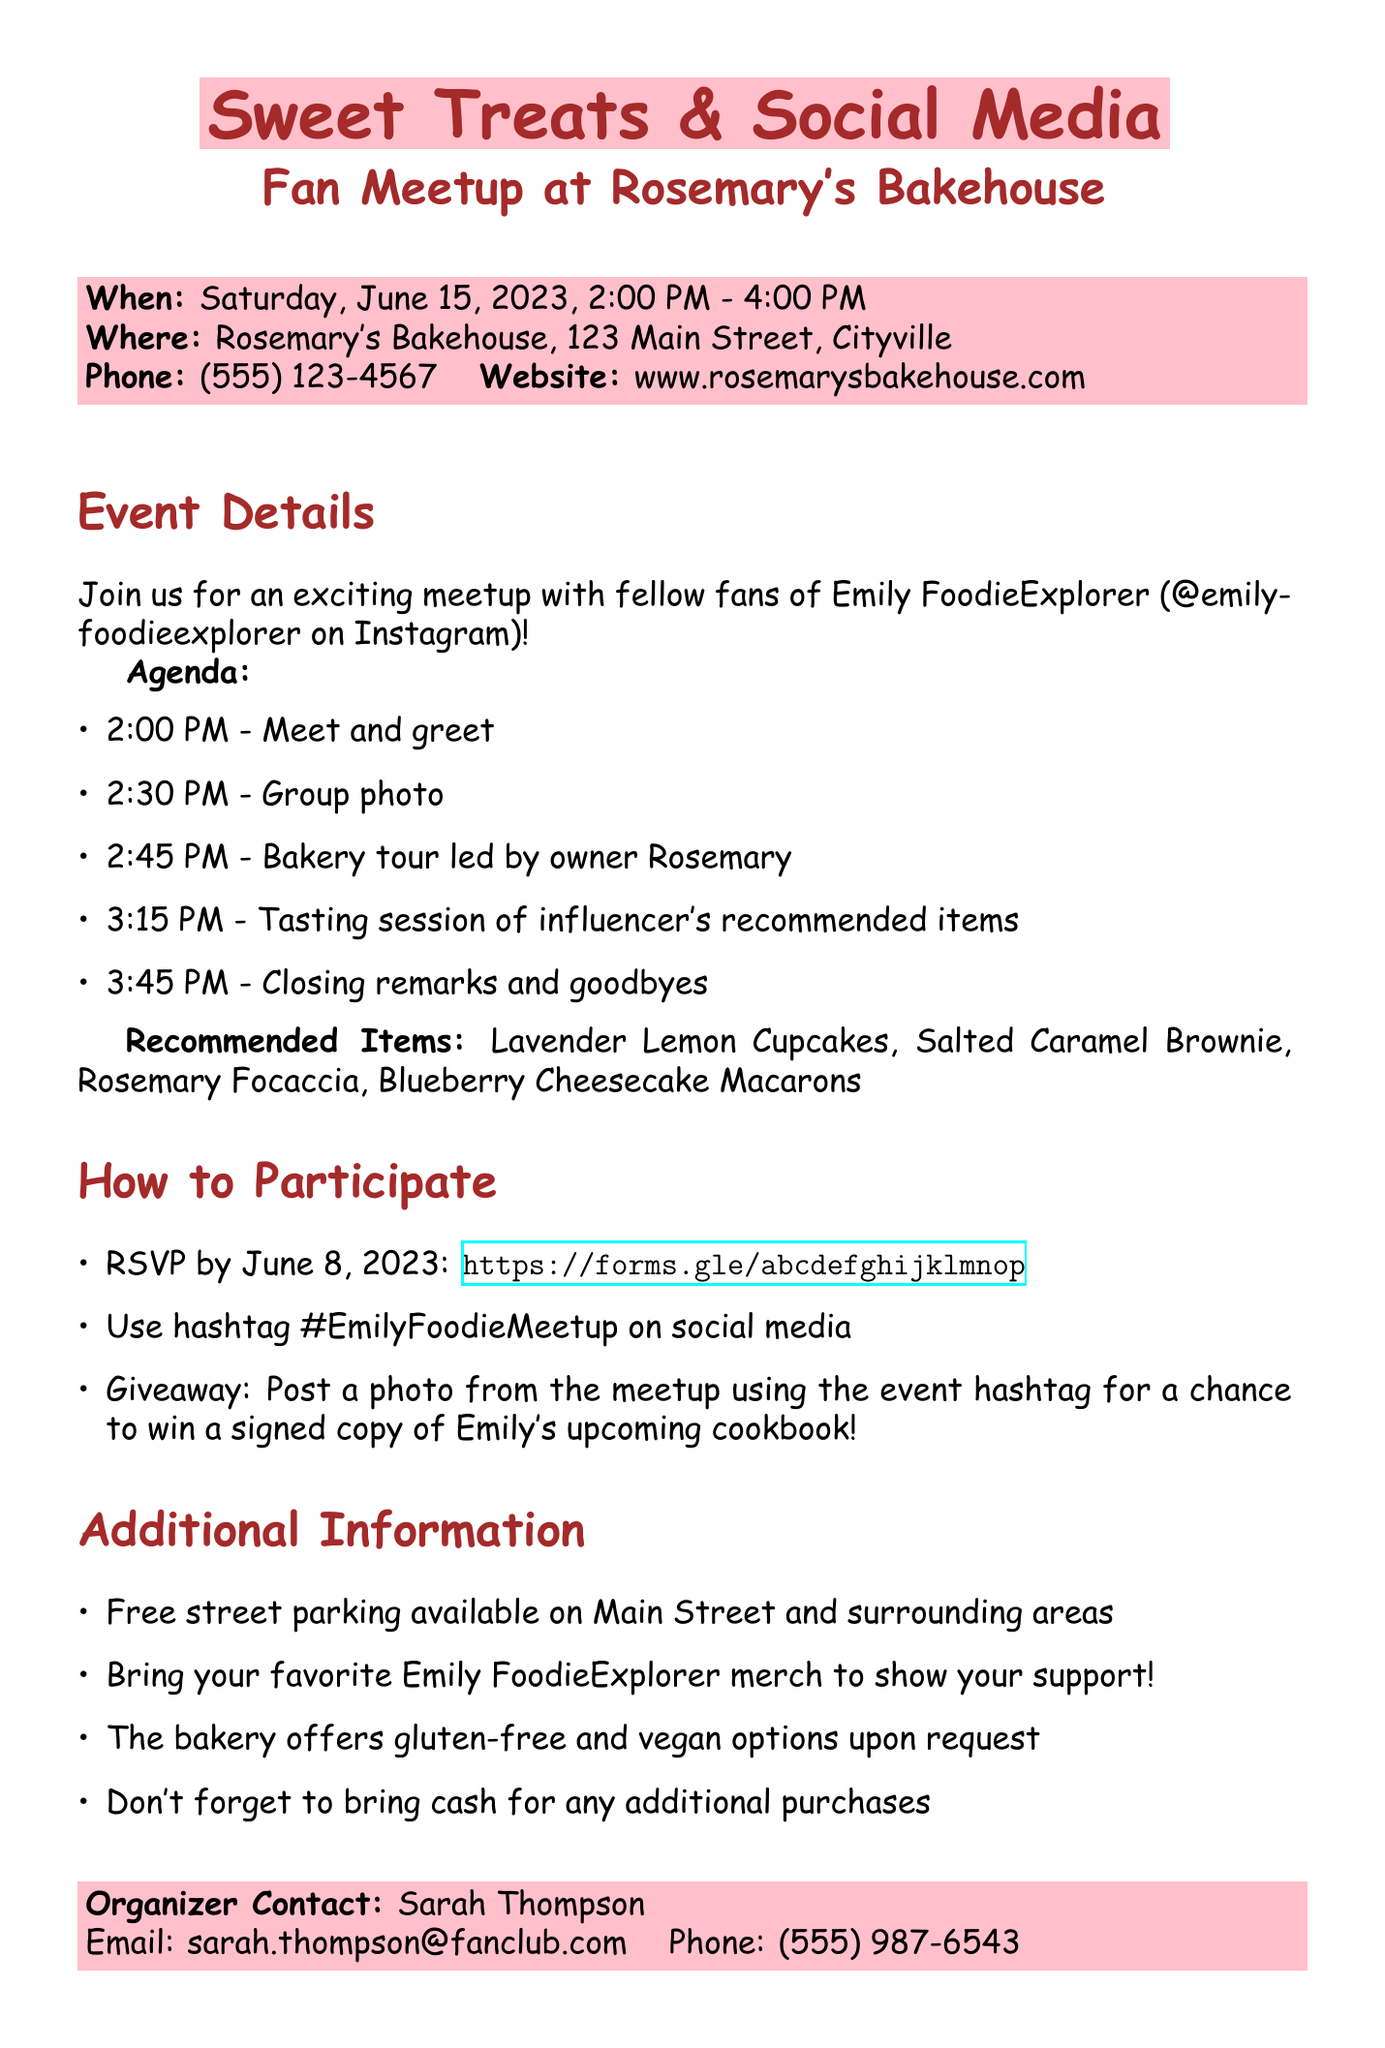What is the title of the meetup? The title of the meetup is the first line of the document, indicating the event.
Answer: Sweet Treats & Social Media: Fan Meetup at Rosemary's Bakehouse Who is the influencer associated with the meetup? The influencer is mentioned in the document and is a key part of the event.
Answer: Emily FoodieExplorer When is the meetup scheduled? The date of the meetup is provided clearly in the document.
Answer: Saturday, June 15, 2023 What time does the tasting session start? The agenda includes specific times for each section, including the tasting session.
Answer: 3:15 PM What is the prize for the giveaway? The giveaway details list what attendees can win at the meetup.
Answer: Signed copy of Emily's upcoming cookbook Where can I RSVP for the event? The RSVP method is clearly stated along with the link provided in the document.
Answer: https://forms.gle/abcdefghijklmnop How long is the meetup scheduled to last? The duration of the event can be calculated from the start and end times provided.
Answer: 2 hours What should attendees bring for extra purchases? Additional notes include advice on what to prepare for the meetup.
Answer: Cash What is the name of the bakery hosting the meetup? The name of the bakery is a prominent detail in the document.
Answer: Rosemary's Bakehouse 